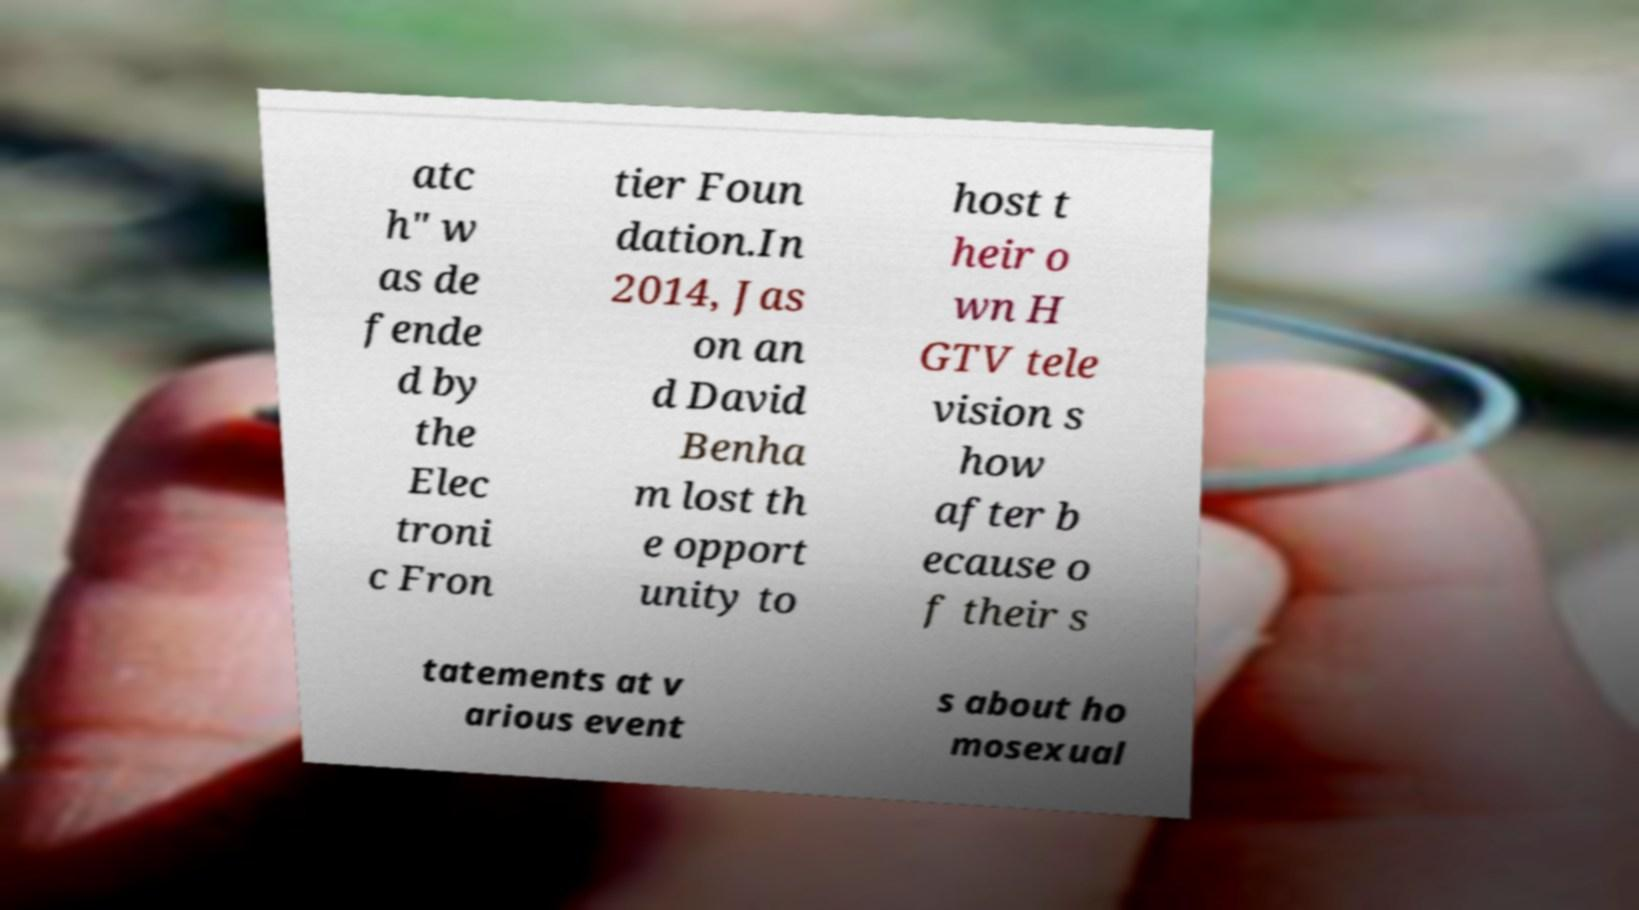There's text embedded in this image that I need extracted. Can you transcribe it verbatim? atc h" w as de fende d by the Elec troni c Fron tier Foun dation.In 2014, Jas on an d David Benha m lost th e opport unity to host t heir o wn H GTV tele vision s how after b ecause o f their s tatements at v arious event s about ho mosexual 